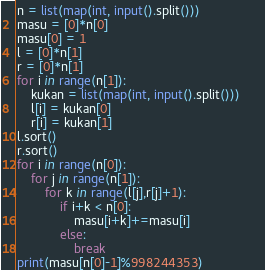Convert code to text. <code><loc_0><loc_0><loc_500><loc_500><_Python_>n = list(map(int, input().split()))
masu = [0]*n[0]
masu[0] = 1
l = [0]*n[1]
r = [0]*n[1]
for i in range(n[1]):
    kukan = list(map(int, input().split()))
    l[i] = kukan[0]
    r[i] = kukan[1]
l.sort()
r.sort()
for i in range(n[0]):
    for j in range(n[1]):
        for k in range(l[j],r[j]+1):
            if i+k < n[0]:
                masu[i+k]+=masu[i]
            else:
                break
print(masu[n[0]-1]%998244353)                 </code> 